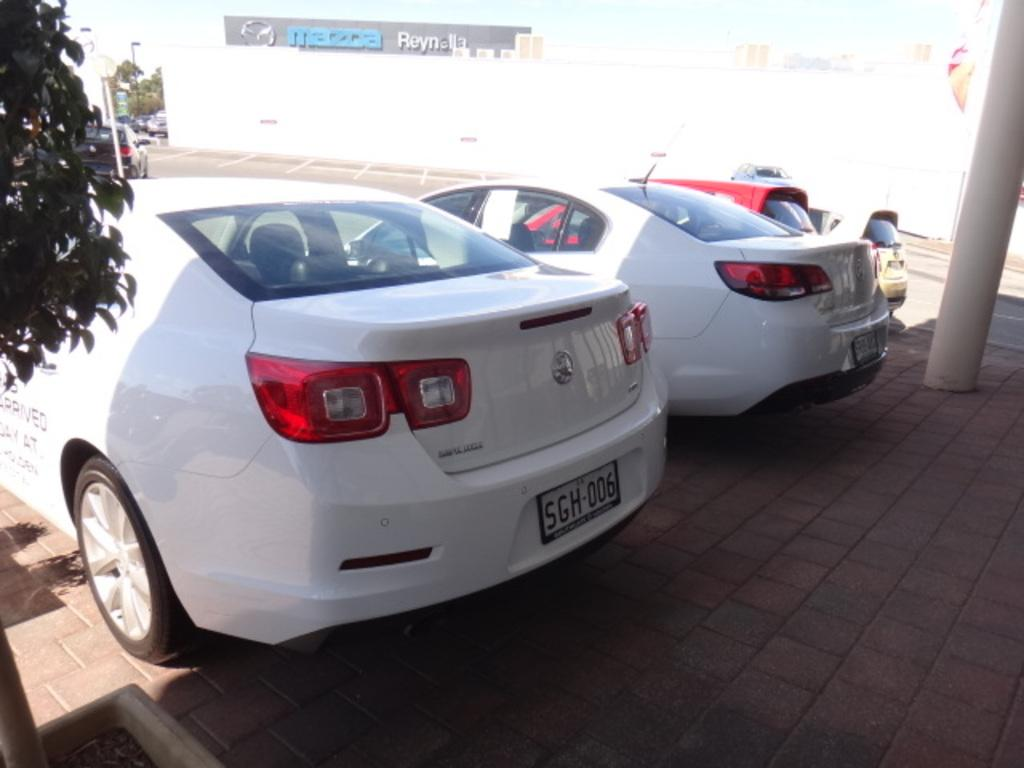Provide a one-sentence caption for the provided image. TWO WHITE SEDANS PARKED REAR END IN ON A BRICK PAVEMENT. 